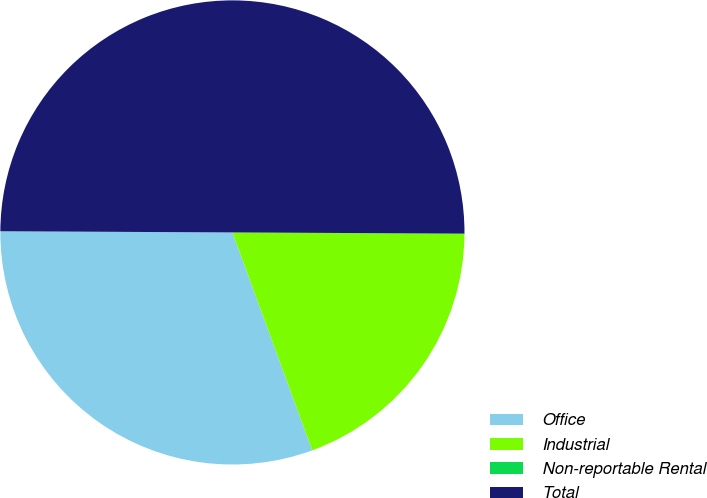Convert chart. <chart><loc_0><loc_0><loc_500><loc_500><pie_chart><fcel>Office<fcel>Industrial<fcel>Non-reportable Rental<fcel>Total<nl><fcel>30.67%<fcel>19.3%<fcel>0.03%<fcel>50.0%<nl></chart> 